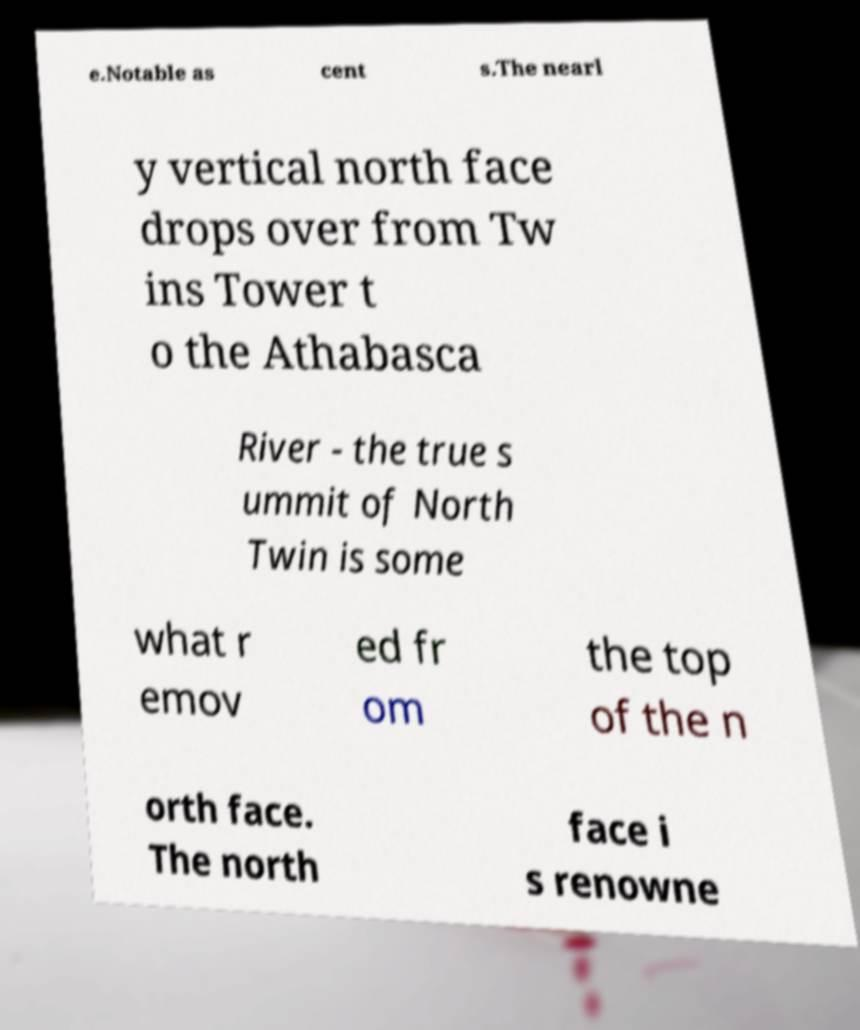For documentation purposes, I need the text within this image transcribed. Could you provide that? e.Notable as cent s.The nearl y vertical north face drops over from Tw ins Tower t o the Athabasca River - the true s ummit of North Twin is some what r emov ed fr om the top of the n orth face. The north face i s renowne 